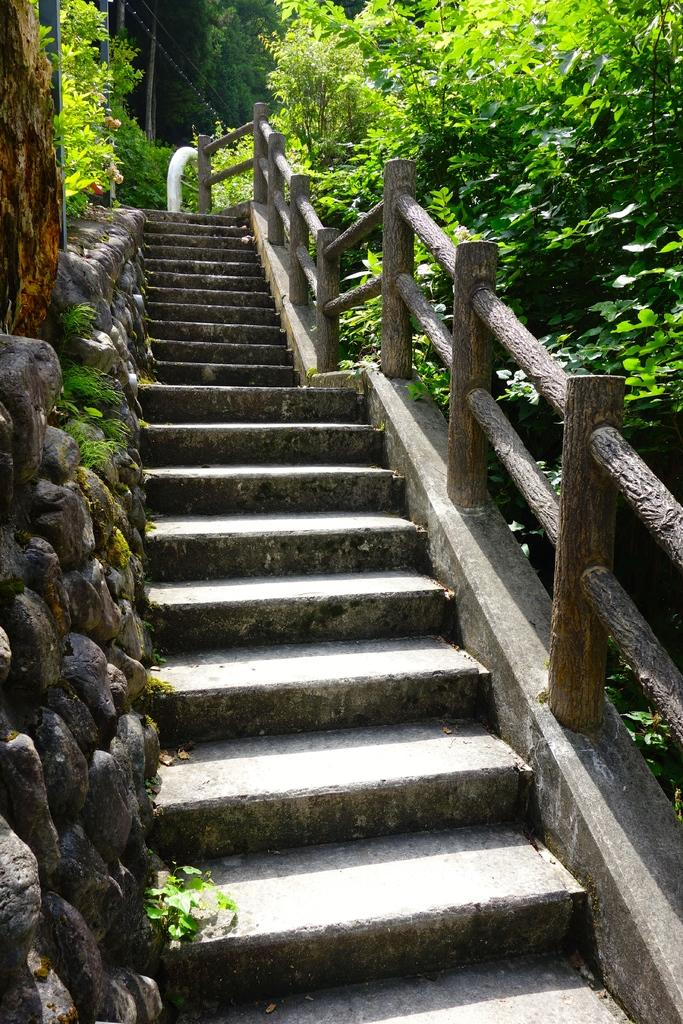What is the main architectural feature in the center of the image? There are stairs in the center of the image. What can be seen on the right side of the image? There is a railing and plants on the right side of the image. What is on the left side of the image? There is a wall and plants on the left side of the image. What type of skirt is being worn by the company in the image? There is no company or skirt present in the image; it features stairs, railing, plants, and a wall. How many times does the image twist around itself? The image does not twist around itself; it is a static representation of the architectural elements mentioned. 